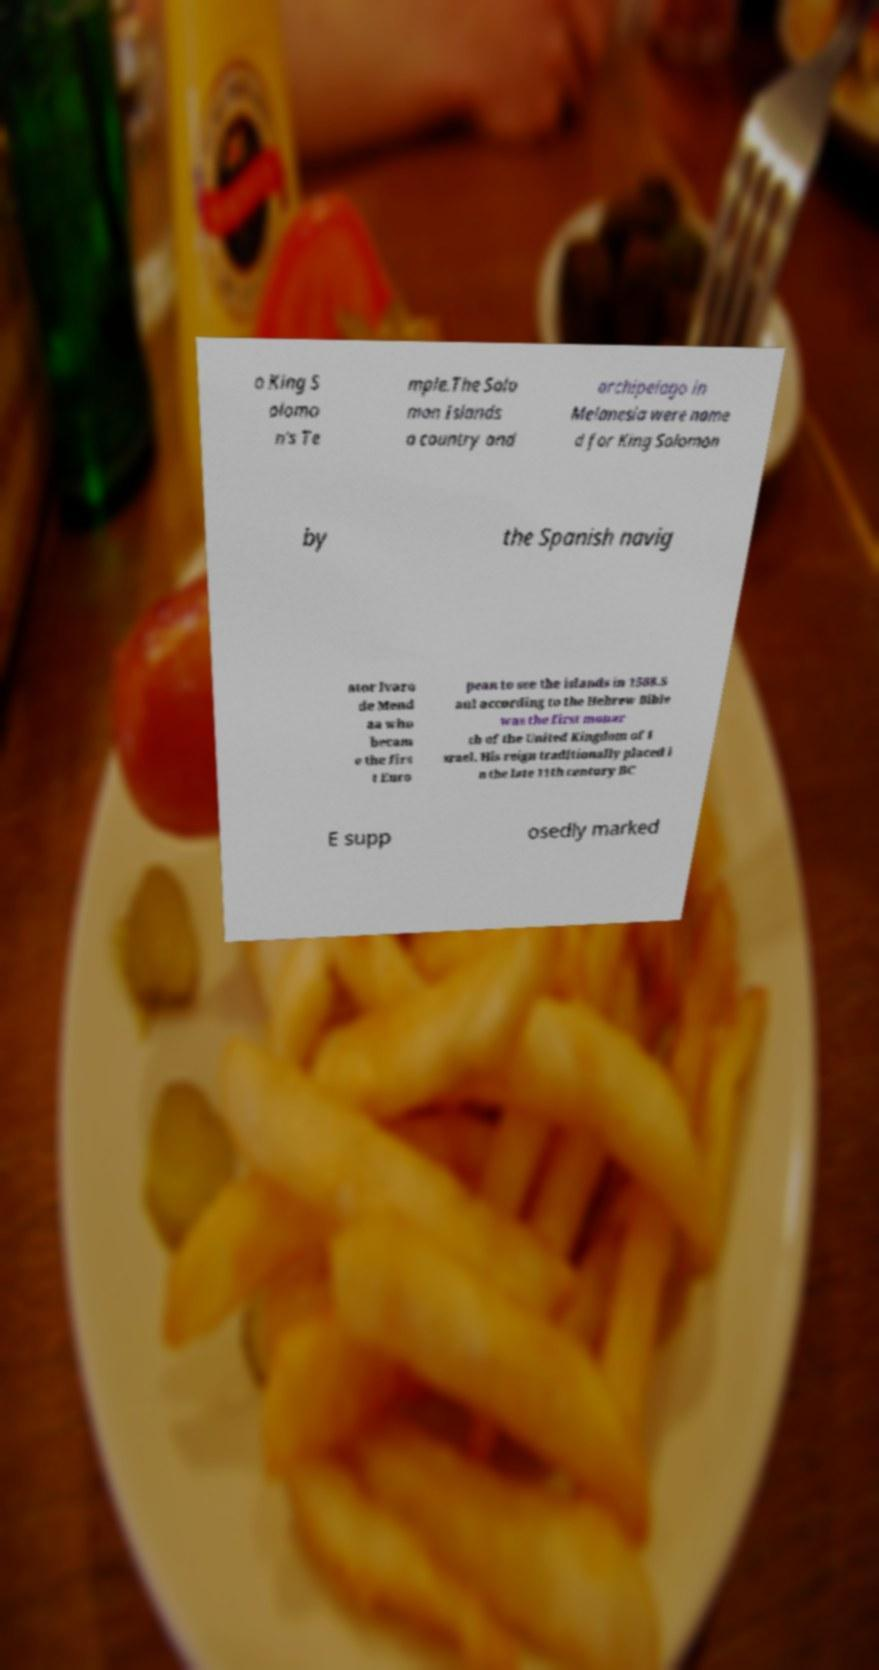Could you extract and type out the text from this image? o King S olomo n's Te mple.The Solo mon Islands a country and archipelago in Melanesia were name d for King Solomon by the Spanish navig ator lvaro de Mend aa who becam e the firs t Euro pean to see the islands in 1568.S aul according to the Hebrew Bible was the first monar ch of the United Kingdom of I srael. His reign traditionally placed i n the late 11th century BC E supp osedly marked 